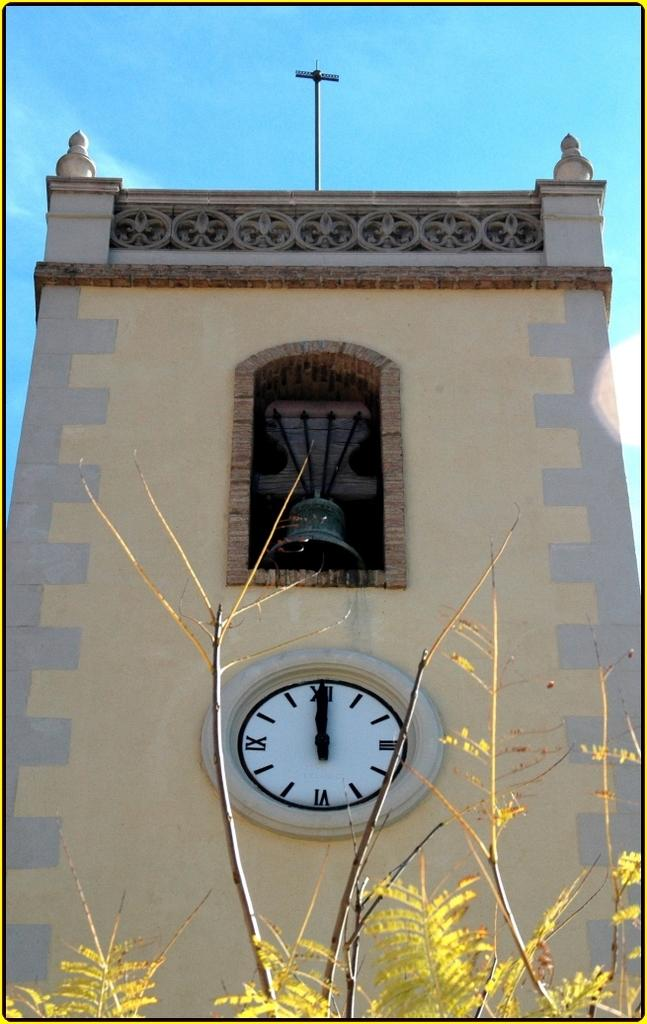What type of structure is visible in the image? There is a building in the image. What feature can be seen on the building? A clock wall is placed on the building. What type of vegetation is at the front of the image? There are trees at the front of the image. What can be seen in the background of the image? The sky is visible in the background of the image. What type of pot is used to power the engine in the image? There is no pot or engine present in the image. How many potatoes are visible in the image? There are no potatoes visible in the image. 